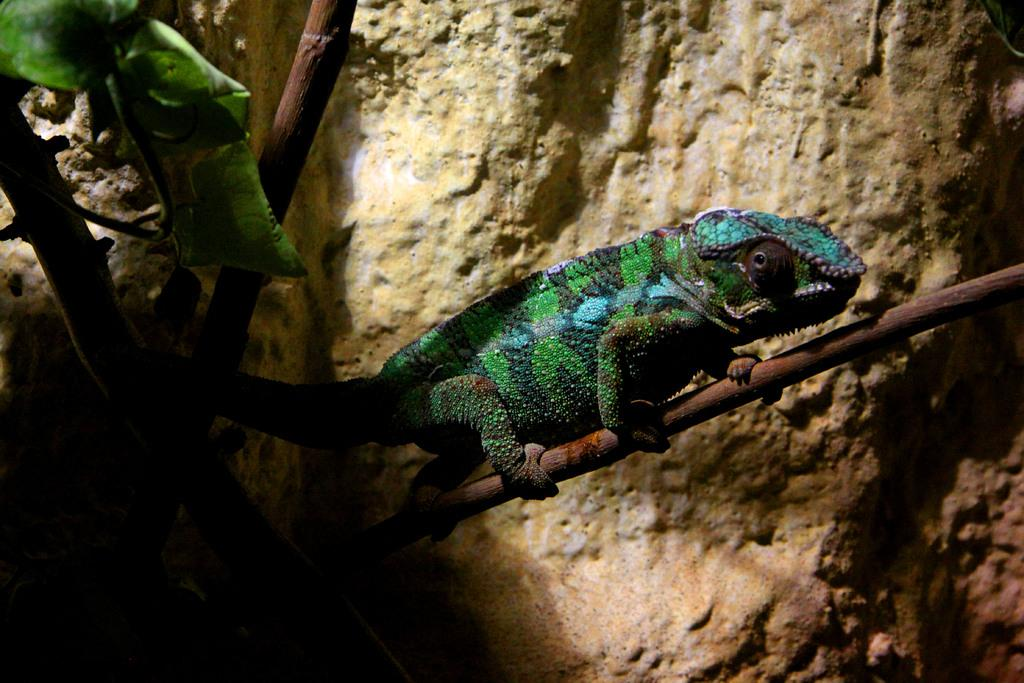What type of animal is in the picture? There is a chameleon in the picture. What colors can be seen on the chameleon? The chameleon is green and blue. Where is the chameleon located in the image? The chameleon is sitting on a plant branch. What can be seen in the background of the image? There is a brown rock visible in the background of the image. What books does the chameleon have an interest in reading in the image? There are no books present in the image, and the chameleon's interests cannot be determined from the image. 